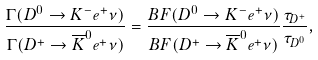Convert formula to latex. <formula><loc_0><loc_0><loc_500><loc_500>\frac { \Gamma ( D ^ { 0 } \rightarrow K ^ { - } e ^ { + } \nu ) } { \Gamma ( D ^ { + } \rightarrow \overline { K } ^ { 0 } e ^ { + } \nu ) } = \frac { B F ( D ^ { 0 } \rightarrow K ^ { - } e ^ { + } \nu ) } { B F ( D ^ { + } \rightarrow \overline { K } ^ { 0 } e ^ { + } \nu ) } \frac { \tau _ { D ^ { + } } } { \tau _ { D ^ { 0 } } } ,</formula> 